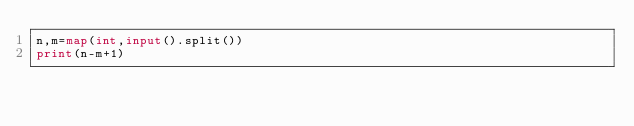<code> <loc_0><loc_0><loc_500><loc_500><_Python_>n,m=map(int,input().split())
print(n-m+1)</code> 